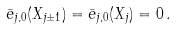<formula> <loc_0><loc_0><loc_500><loc_500>\bar { e } _ { j , 0 } ( X _ { j \pm 1 } ) = \bar { e } _ { j , 0 } ( X _ { j } ) = 0 \, .</formula> 